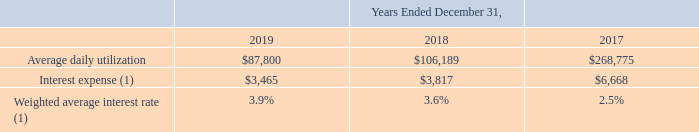The following table presents information related to our credit agreements (dollars in thousands):
(1) Excludes the amortization of deferred loan fees and includes the commitment fee.
In January 2018, the Company repaid $175.0 million of long-term debt outstanding under its 2015 Credit Agreement, primarily using funds repatriated from its foreign subsidiaries.
What was the interest expense in 2019?
Answer scale should be: thousand. $3,465. What does interest expense exclude? The amortization of deferred loan fees and includes the commitment fee. In which years is information related to the credit agreements provided? 2019, 2018, 2017. In which year was the amount of Interest expense the smallest? 3,465<3,817<6,668
Answer: 2019. What was the change in Interest expense in 2019 from 2018?
Answer scale should be: thousand. $3,465-$3,817
Answer: -352. What was the percentage change in Interest expense in 2019 from 2018?
Answer scale should be: percent. ($3,465-$3,817)/$3,817
Answer: -9.22. 